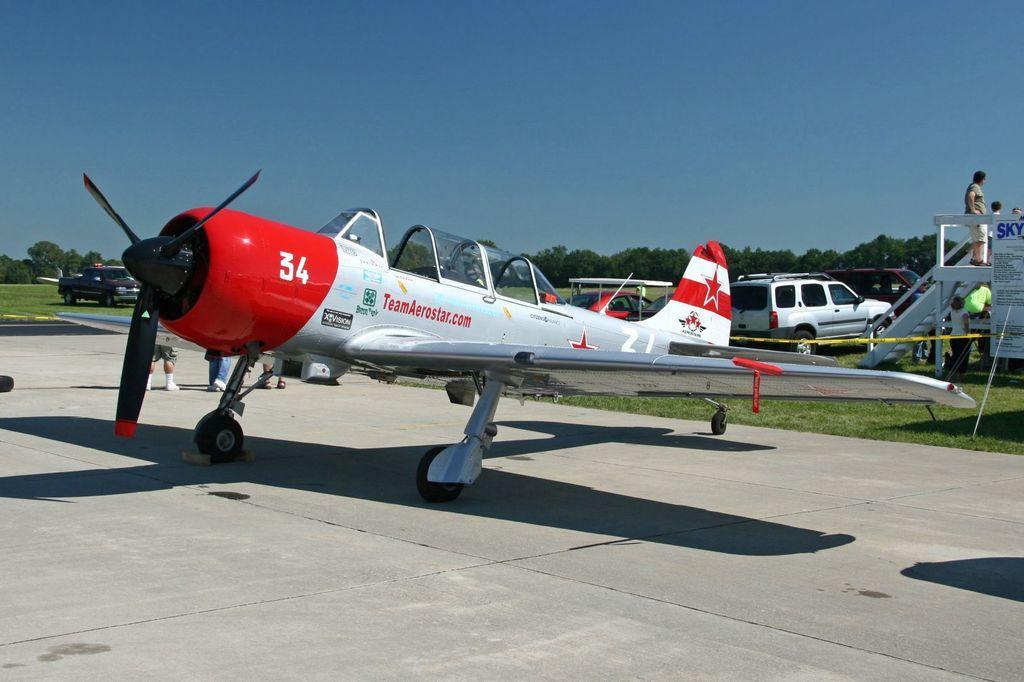Can you describe this image briefly? In this picture there is an aircraft. At the back there are group of people walking behind the aircraft. At the back there are vehicles. On the right side of the image there are group of people, there is a person standing on the staircase and there is a hoarding to the stair case. At the back there are trees. At the top there is sky. At the bottom there is grass. 